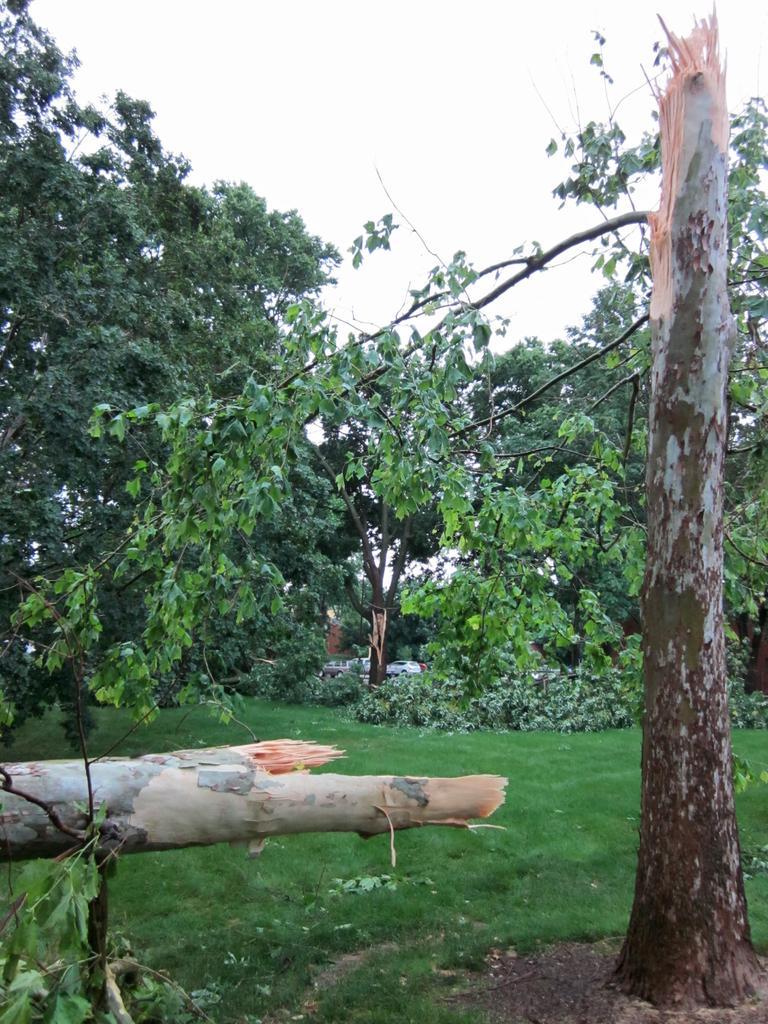Describe this image in one or two sentences. There is a lot of greenery with tall trees, plants around the grass. 